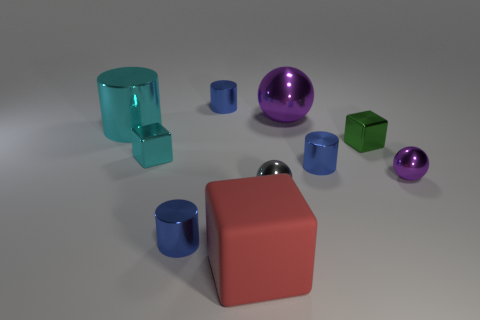Are the objects shown in the image real or are they computer-generated? The objects in the image present with impeccably smooth surfaces and uniform lighting, which often suggests that they might be computer-generated, often used in graphics design to illustrate concepts involving geometry and spatial relationships. 